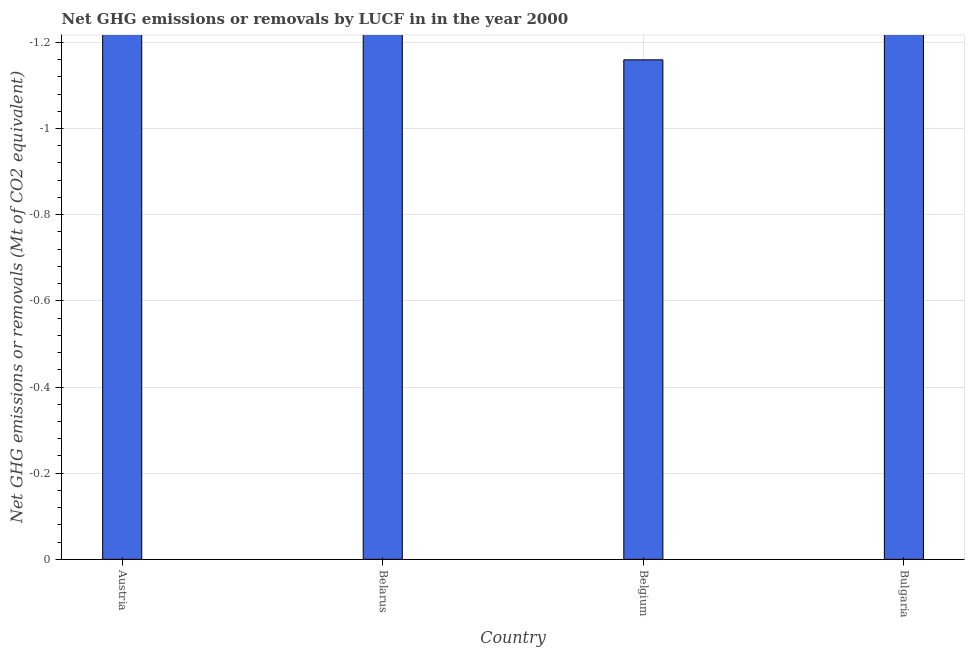What is the title of the graph?
Your answer should be compact. Net GHG emissions or removals by LUCF in in the year 2000. What is the label or title of the Y-axis?
Make the answer very short. Net GHG emissions or removals (Mt of CO2 equivalent). Across all countries, what is the minimum ghg net emissions or removals?
Offer a terse response. 0. What is the average ghg net emissions or removals per country?
Provide a succinct answer. 0. What is the median ghg net emissions or removals?
Provide a short and direct response. 0. What is the difference between two consecutive major ticks on the Y-axis?
Your answer should be very brief. 0.2. Are the values on the major ticks of Y-axis written in scientific E-notation?
Ensure brevity in your answer.  No. What is the Net GHG emissions or removals (Mt of CO2 equivalent) of Belgium?
Give a very brief answer. 0. What is the Net GHG emissions or removals (Mt of CO2 equivalent) in Bulgaria?
Provide a succinct answer. 0. 